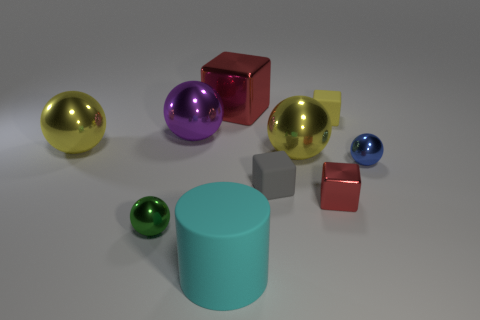Subtract all green balls. How many balls are left? 4 Subtract 1 balls. How many balls are left? 4 Subtract all small blue balls. How many balls are left? 4 Subtract all brown balls. Subtract all brown cylinders. How many balls are left? 5 Subtract all blocks. How many objects are left? 6 Add 2 big yellow balls. How many big yellow balls are left? 4 Add 7 tiny rubber blocks. How many tiny rubber blocks exist? 9 Subtract 0 purple cylinders. How many objects are left? 10 Subtract all cubes. Subtract all brown blocks. How many objects are left? 6 